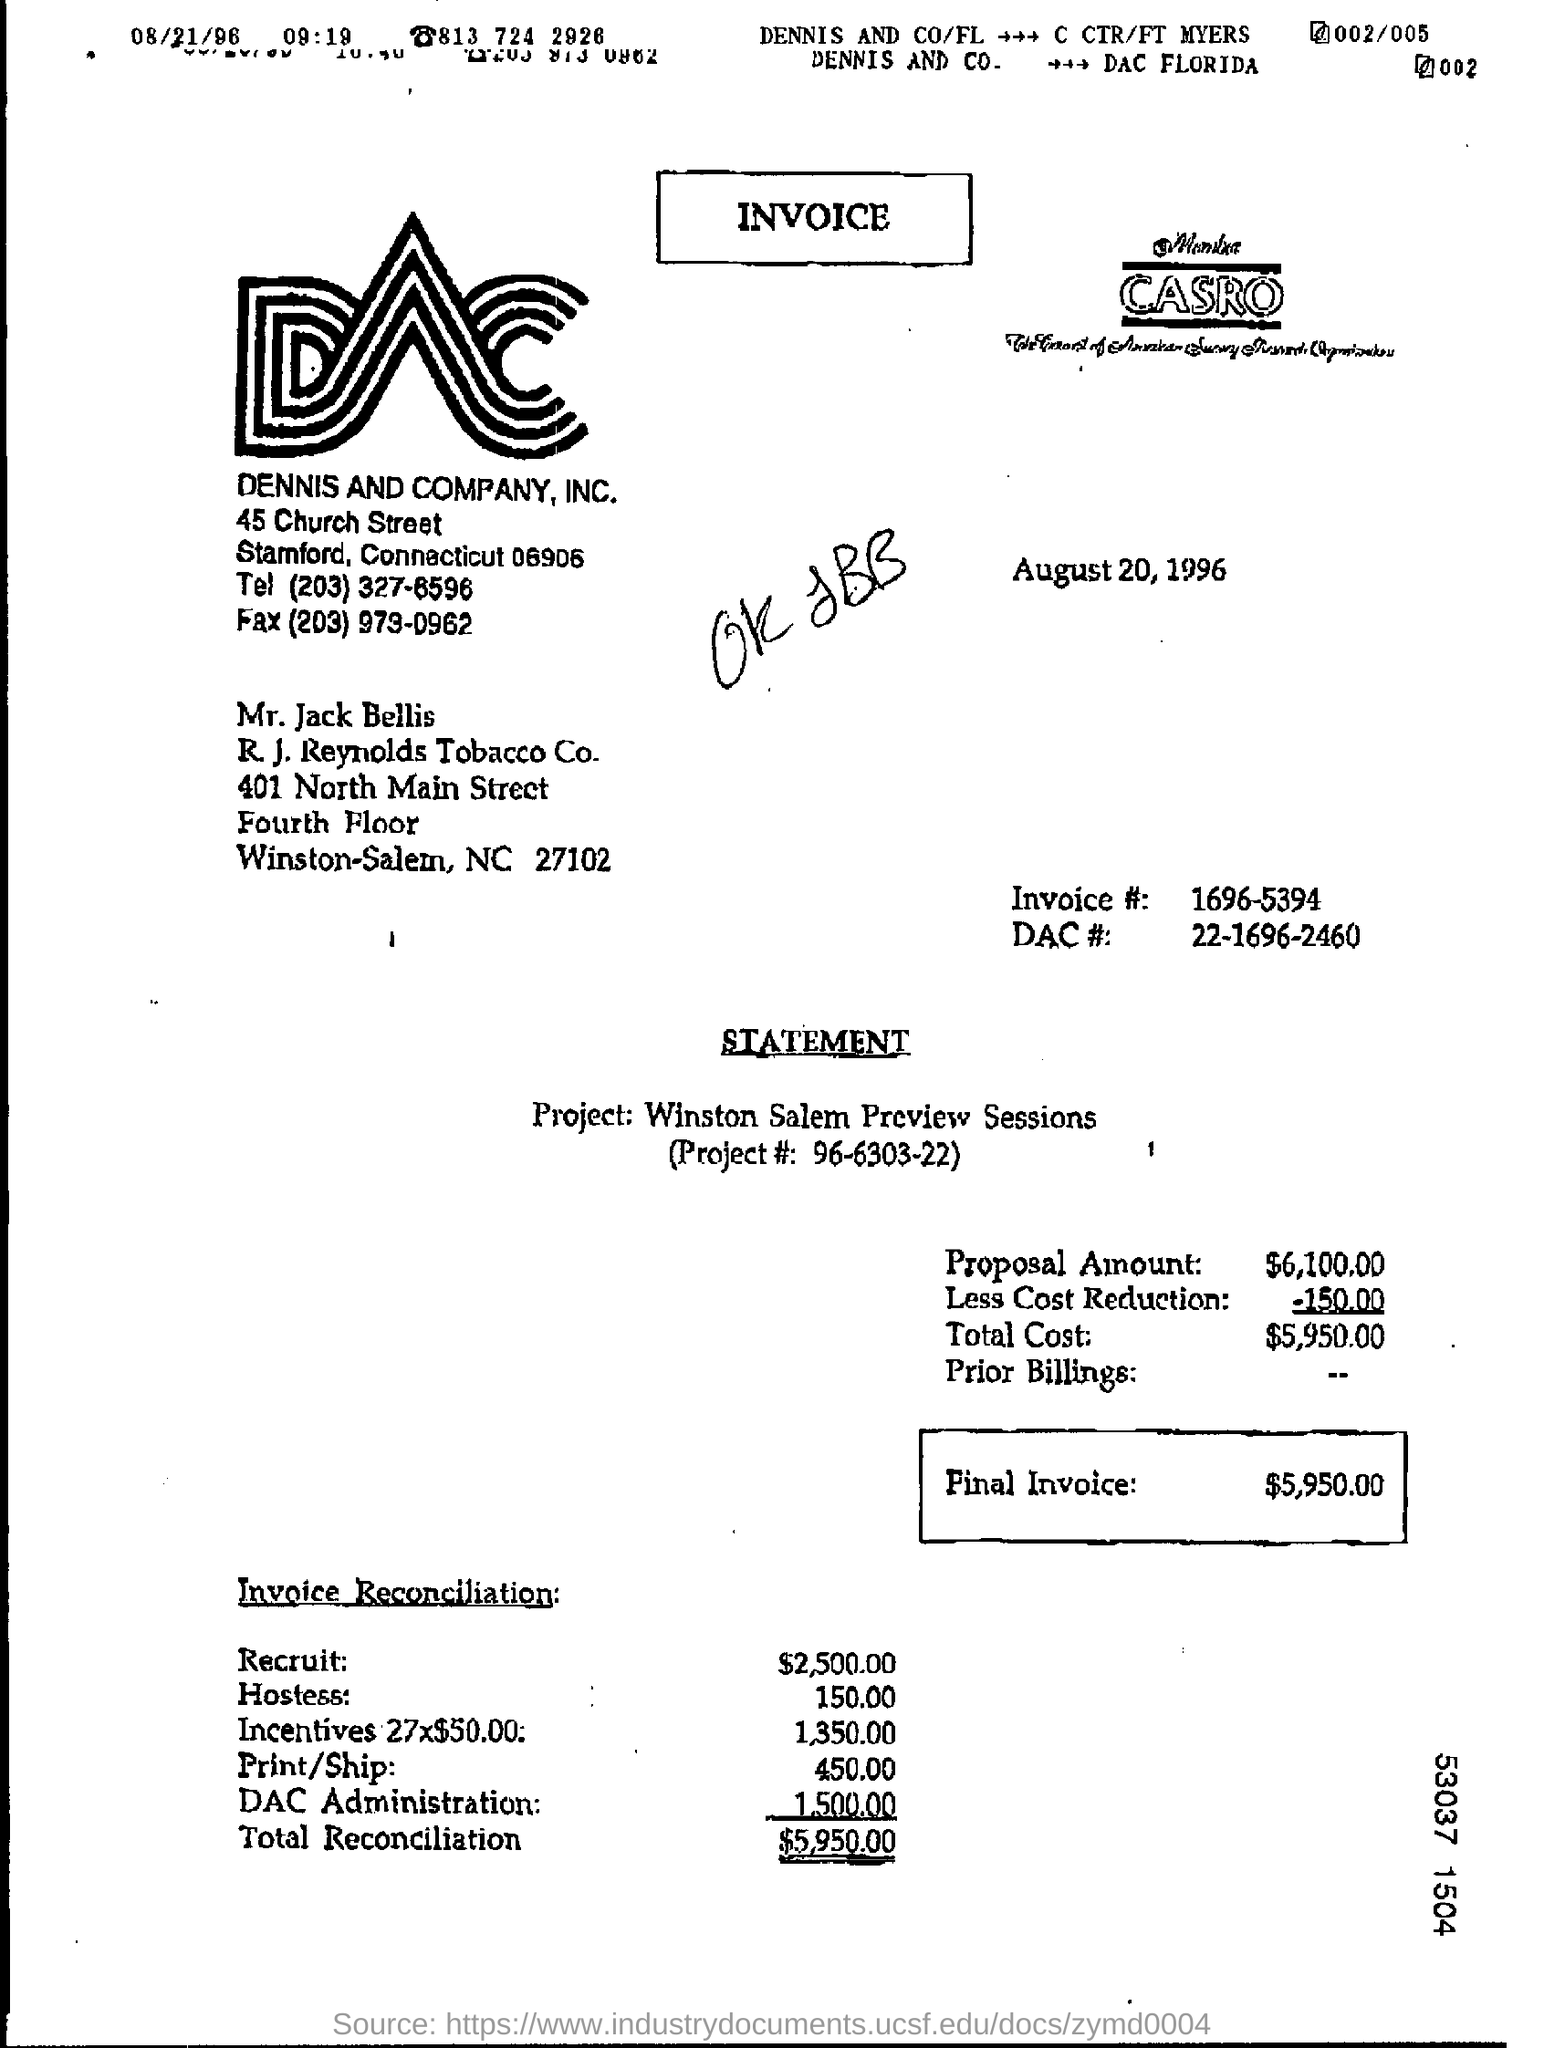Point out several critical features in this image. The total reconciliation amount is $5,950.00. The invoice number is 1696-5394. This invoice is related to the Winston Salem Preview Sessions project. The heading of the document is "Invoice. The proposal amount is $6,100.00. 